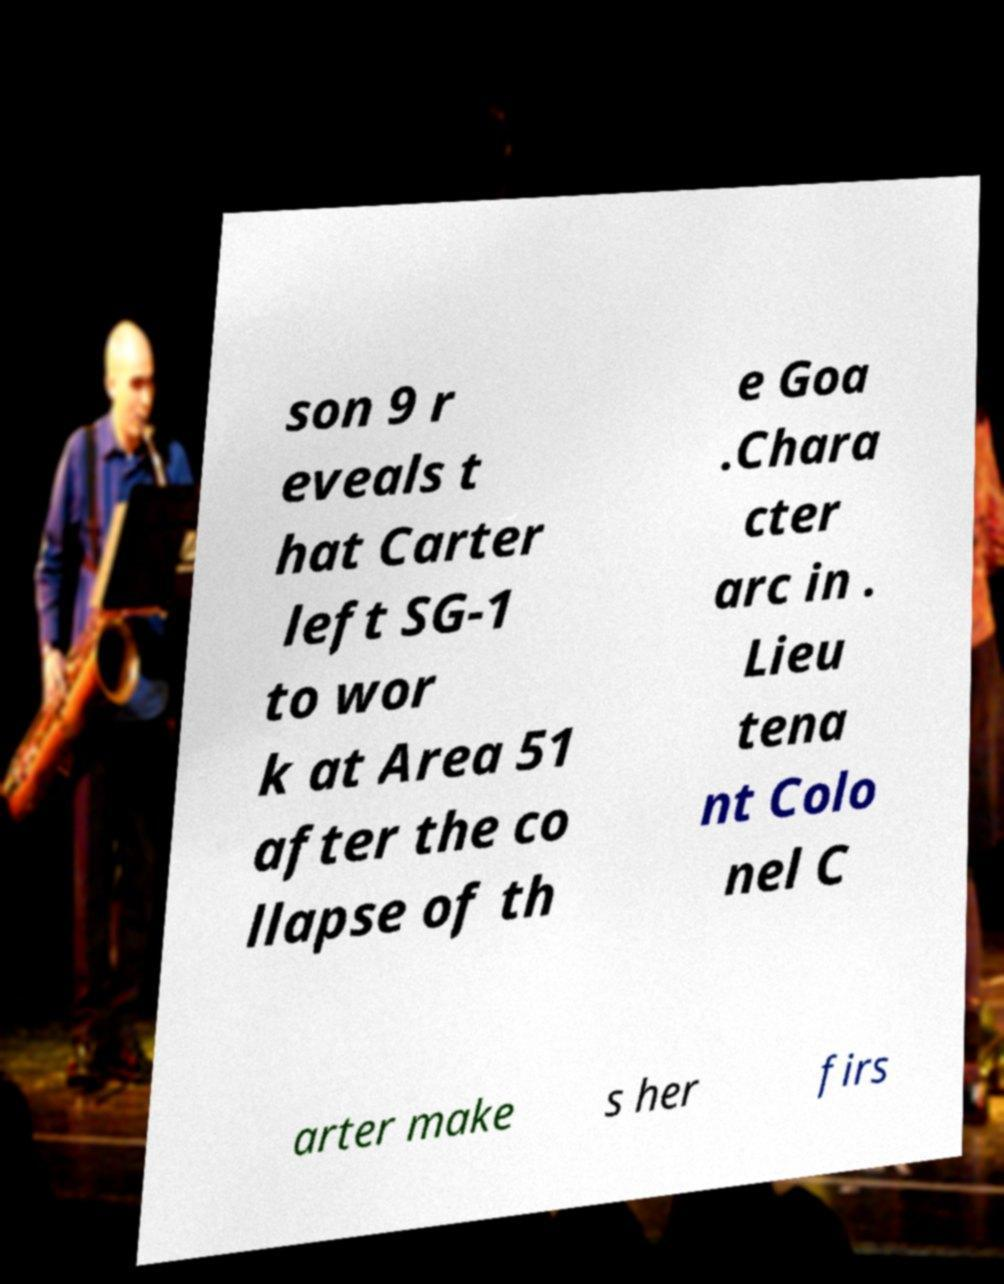What messages or text are displayed in this image? I need them in a readable, typed format. son 9 r eveals t hat Carter left SG-1 to wor k at Area 51 after the co llapse of th e Goa .Chara cter arc in . Lieu tena nt Colo nel C arter make s her firs 